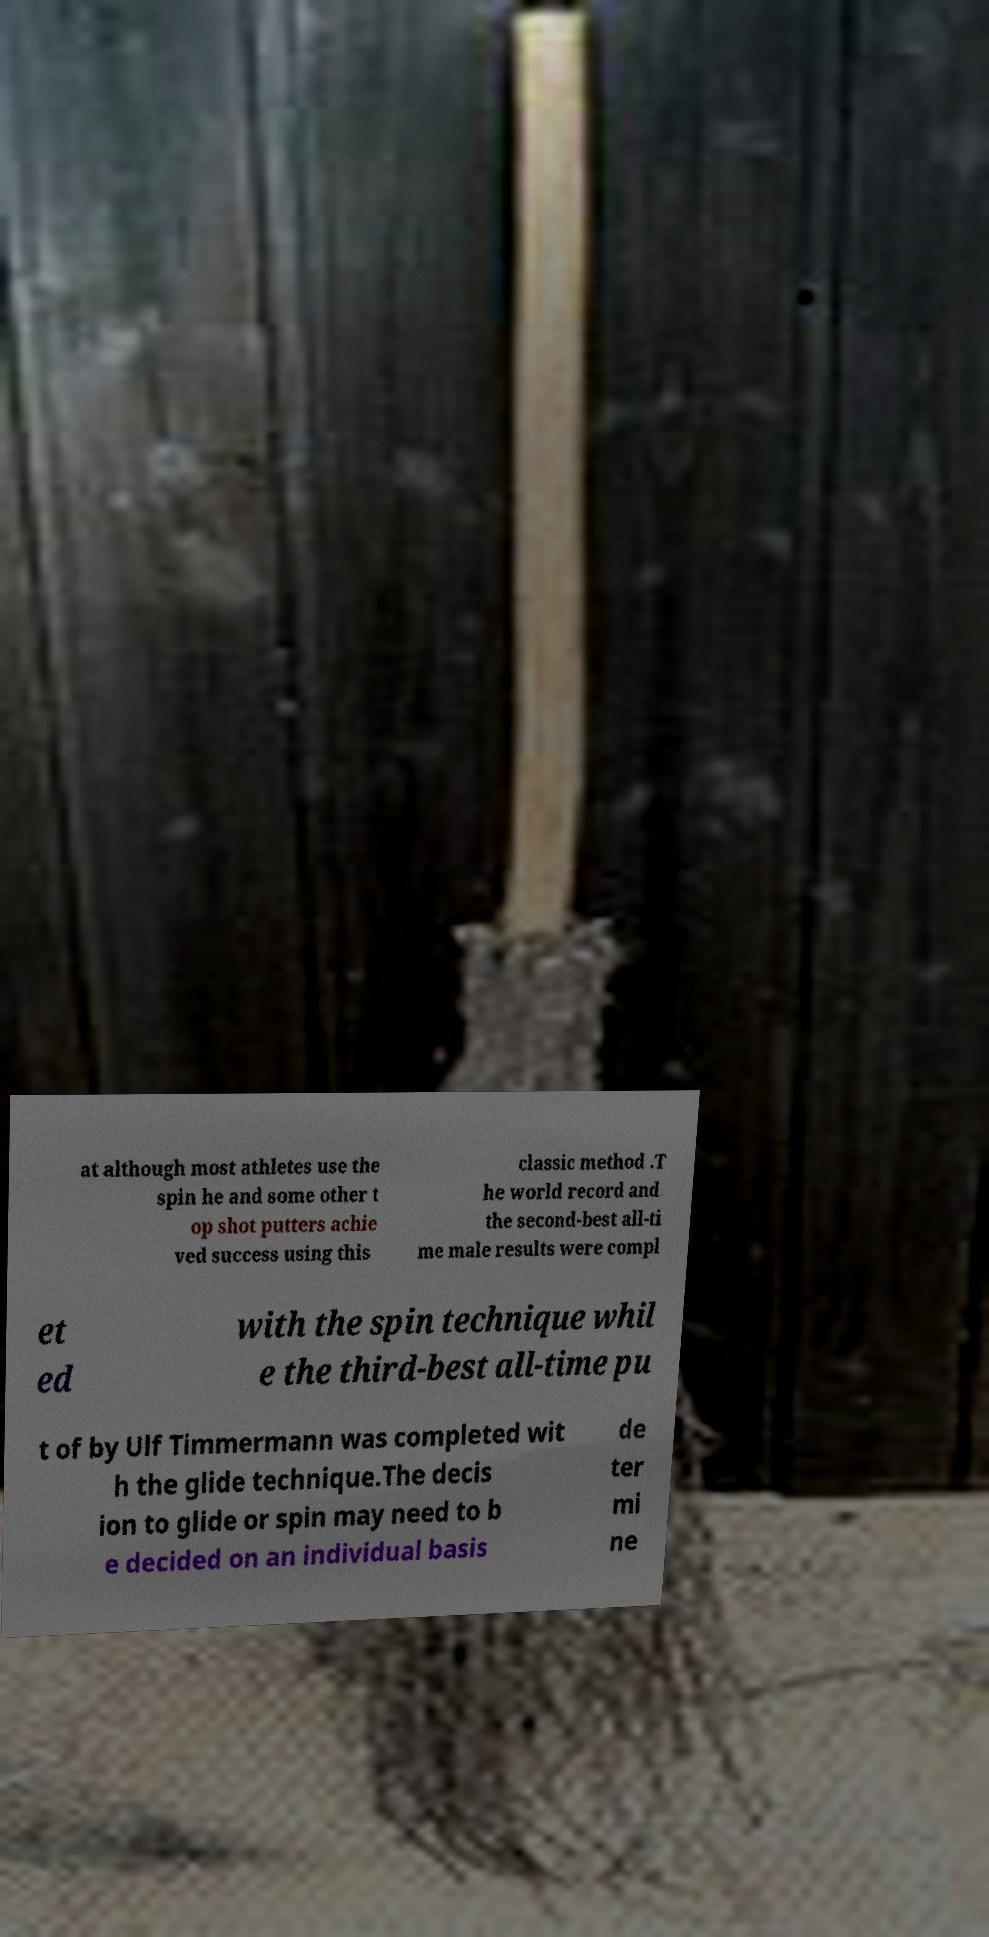Can you accurately transcribe the text from the provided image for me? at although most athletes use the spin he and some other t op shot putters achie ved success using this classic method .T he world record and the second-best all-ti me male results were compl et ed with the spin technique whil e the third-best all-time pu t of by Ulf Timmermann was completed wit h the glide technique.The decis ion to glide or spin may need to b e decided on an individual basis de ter mi ne 